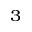<formula> <loc_0><loc_0><loc_500><loc_500>^ { 3 }</formula> 